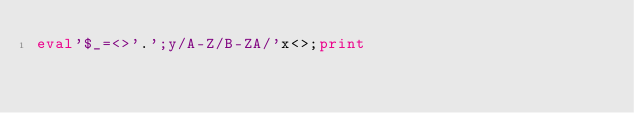<code> <loc_0><loc_0><loc_500><loc_500><_Perl_>eval'$_=<>'.';y/A-Z/B-ZA/'x<>;print</code> 